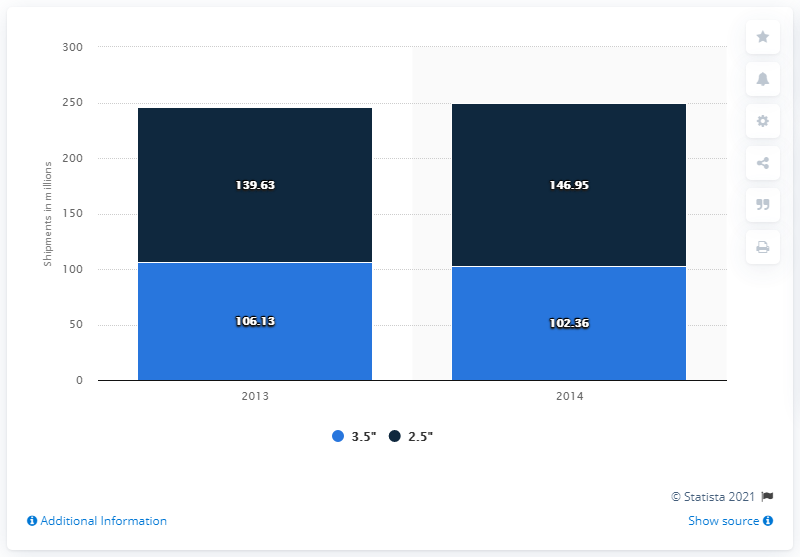Identify some key points in this picture. The graph represents two to five years. In 2014, the value was the highest among all the years. WDC shipped 102,360 3.5-inch hard disk drives in 2014. 